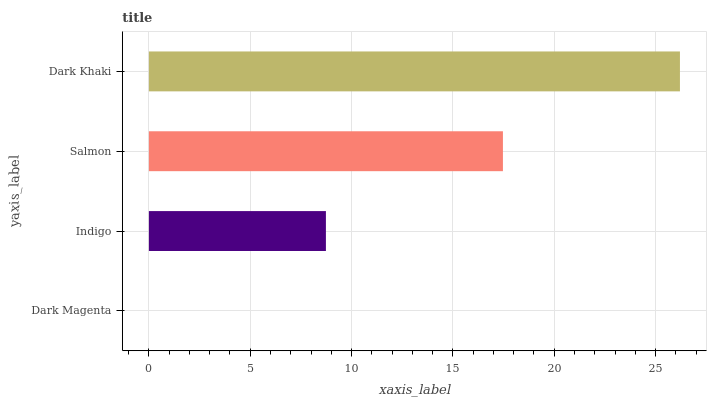Is Dark Magenta the minimum?
Answer yes or no. Yes. Is Dark Khaki the maximum?
Answer yes or no. Yes. Is Indigo the minimum?
Answer yes or no. No. Is Indigo the maximum?
Answer yes or no. No. Is Indigo greater than Dark Magenta?
Answer yes or no. Yes. Is Dark Magenta less than Indigo?
Answer yes or no. Yes. Is Dark Magenta greater than Indigo?
Answer yes or no. No. Is Indigo less than Dark Magenta?
Answer yes or no. No. Is Salmon the high median?
Answer yes or no. Yes. Is Indigo the low median?
Answer yes or no. Yes. Is Indigo the high median?
Answer yes or no. No. Is Salmon the low median?
Answer yes or no. No. 